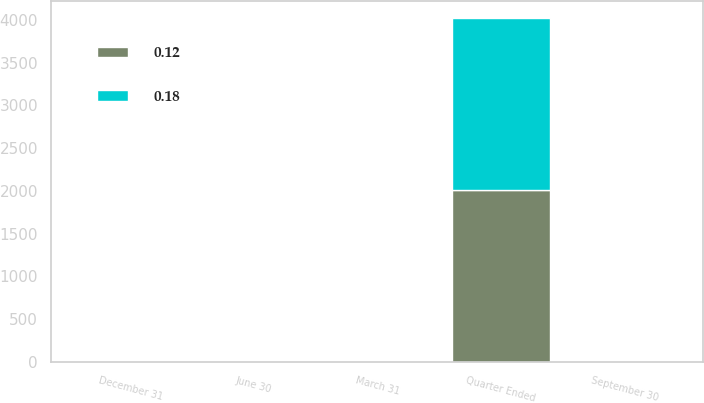<chart> <loc_0><loc_0><loc_500><loc_500><stacked_bar_chart><ecel><fcel>Quarter Ended<fcel>December 31<fcel>September 30<fcel>June 30<fcel>March 31<nl><fcel>0.12<fcel>2012<fcel>0.2<fcel>0.2<fcel>0.18<fcel>0.18<nl><fcel>0.18<fcel>2011<fcel>0.27<fcel>0.12<fcel>0.12<fcel>0.12<nl></chart> 